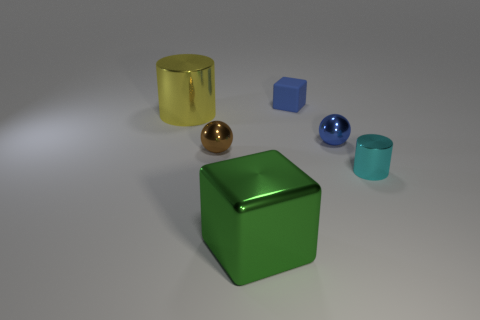How many things are either large yellow metal objects or rubber cubes?
Your response must be concise. 2. There is a blue object in front of the large yellow metal cylinder; is its size the same as the shiny sphere that is left of the green object?
Your answer should be compact. Yes. Are there any yellow shiny objects of the same shape as the small blue rubber thing?
Offer a very short reply. No. Are there fewer cyan shiny cylinders that are behind the blue ball than small red rubber blocks?
Make the answer very short. No. Is the shape of the big green shiny object the same as the tiny matte thing?
Provide a short and direct response. Yes. What size is the sphere right of the green metal object?
Provide a succinct answer. Small. The cube that is the same material as the large cylinder is what size?
Your answer should be compact. Large. Are there fewer green shiny cubes than small purple rubber cylinders?
Offer a very short reply. No. There is a blue cube that is the same size as the blue ball; what is it made of?
Keep it short and to the point. Rubber. Is the number of purple cylinders greater than the number of metallic spheres?
Keep it short and to the point. No. 